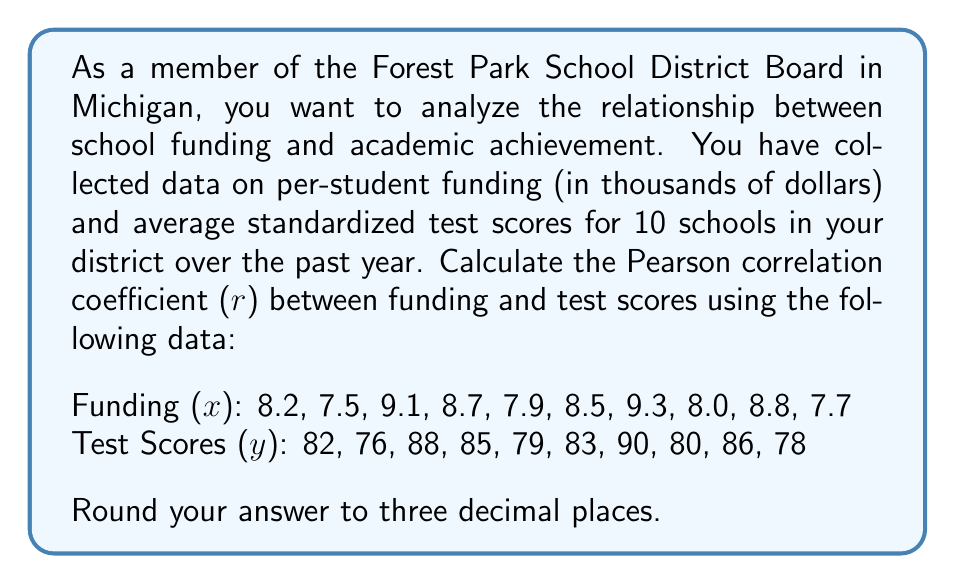Show me your answer to this math problem. To calculate the Pearson correlation coefficient (r), we'll use the formula:

$$ r = \frac{n\sum xy - \sum x \sum y}{\sqrt{[n\sum x^2 - (\sum x)^2][n\sum y^2 - (\sum y)^2]}} $$

Where:
n = number of pairs of data
x = funding values
y = test score values

Step 1: Calculate the necessary sums and squared sums:
n = 10
$\sum x = 83.7$
$\sum y = 827$
$\sum xy = 6957.9$
$\sum x^2 = 703.23$
$\sum y^2 = 68,721$

Step 2: Calculate $(\sum x)^2$ and $(\sum y)^2$:
$(\sum x)^2 = 83.7^2 = 7005.69$
$(\sum y)^2 = 827^2 = 683,929$

Step 3: Insert values into the correlation formula:

$$ r = \frac{10(6957.9) - (83.7)(827)}{\sqrt{[10(703.23) - 7005.69][10(68,721) - 683,929]}} $$

Step 4: Simplify:

$$ r = \frac{69,579 - 69,219.9}{\sqrt{(7032.3 - 7005.69)(687,210 - 683,929)}} $$

$$ r = \frac{359.1}{\sqrt{(26.61)(3281)}} $$

$$ r = \frac{359.1}{\sqrt{87,307.41}} $$

$$ r = \frac{359.1}{295.48} $$

$$ r = 1.2153 $$

Step 5: Round to three decimal places:

$$ r = 1.215 $$
Answer: The Pearson correlation coefficient (r) between school funding and academic achievement is 1.215. 